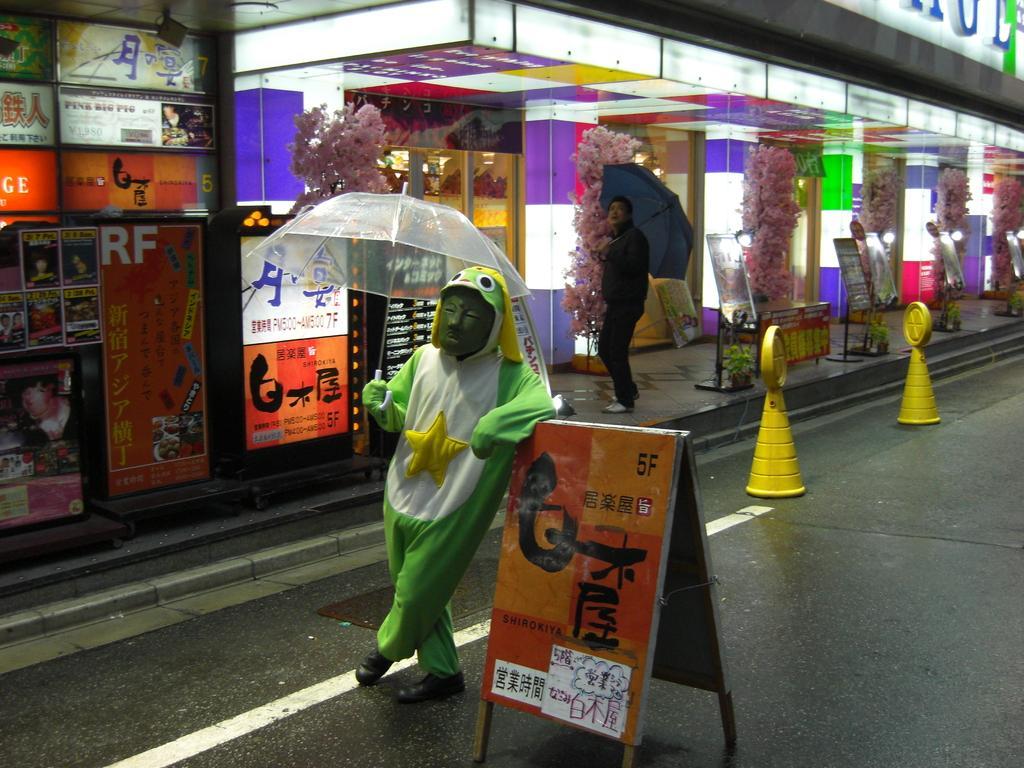How would you summarize this image in a sentence or two? In this picture there is a man who is wearing mask, green jacket and black shoes. He is holding an umbrella. Beside him there is a advertisement board. On the left there are two yellow traffic cones on the road. In front of the door there is a man who is wearing black dress. shoes and holding an umbrella. Besides I can see some plants and fencing. In the background I can see the building. On the left I can see the posts which were placed on the wall. 